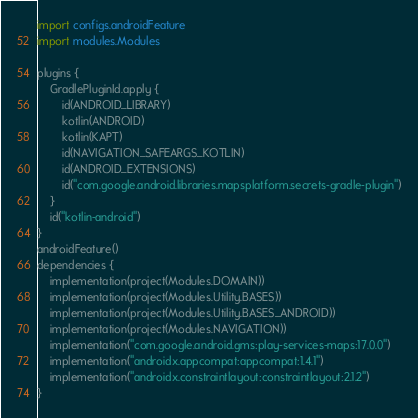Convert code to text. <code><loc_0><loc_0><loc_500><loc_500><_Kotlin_>import configs.androidFeature
import modules.Modules

plugins {
    GradlePluginId.apply {
        id(ANDROID_LIBRARY)
        kotlin(ANDROID)
        kotlin(KAPT)
        id(NAVIGATION_SAFEARGS_KOTLIN)
        id(ANDROID_EXTENSIONS)
        id("com.google.android.libraries.mapsplatform.secrets-gradle-plugin")
    }
    id("kotlin-android")
}
androidFeature()
dependencies {
    implementation(project(Modules.DOMAIN))
    implementation(project(Modules.Utility.BASES))
    implementation(project(Modules.Utility.BASES_ANDROID))
    implementation(project(Modules.NAVIGATION))
    implementation("com.google.android.gms:play-services-maps:17.0.0")
    implementation("androidx.appcompat:appcompat:1.4.1")
    implementation("androidx.constraintlayout:constraintlayout:2.1.2")
}</code> 